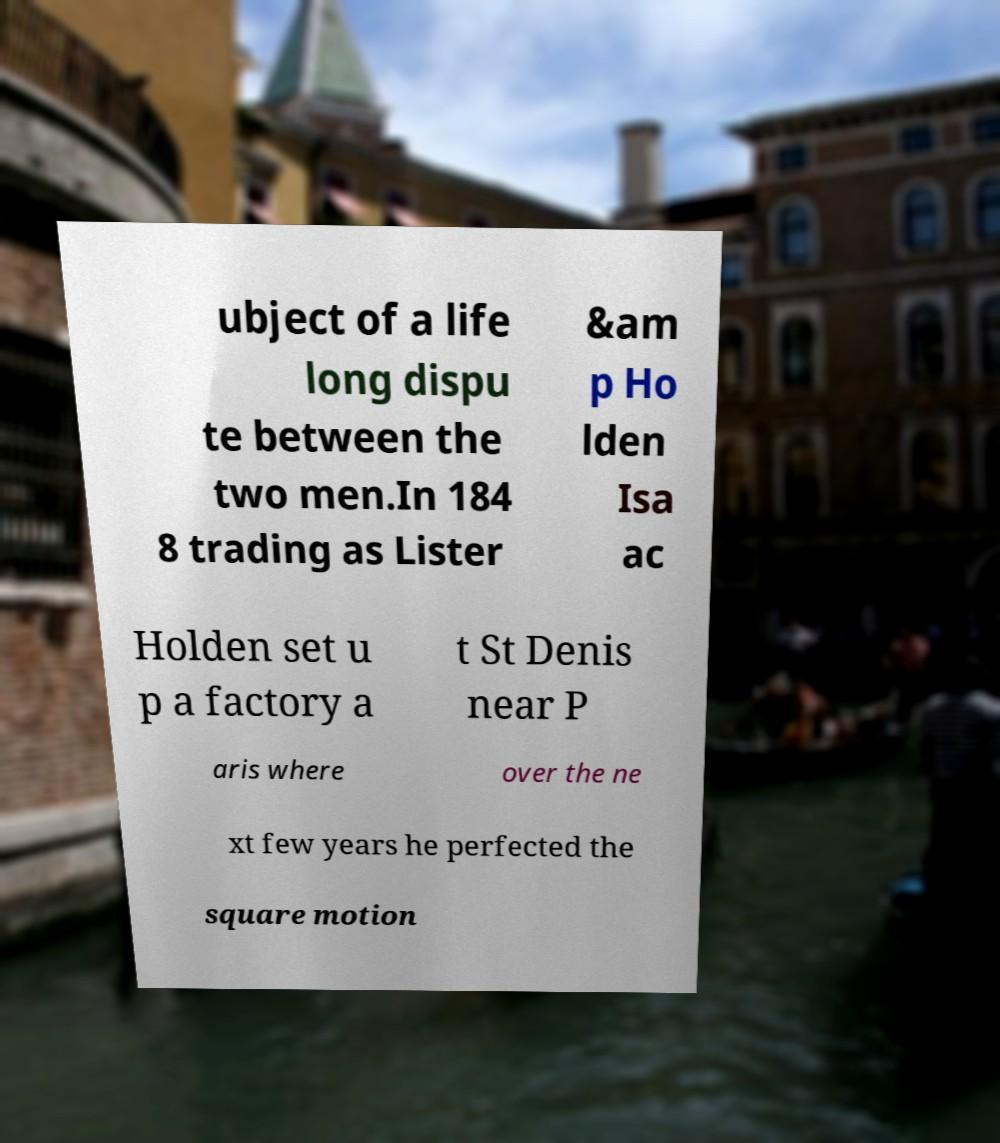Can you read and provide the text displayed in the image?This photo seems to have some interesting text. Can you extract and type it out for me? ubject of a life long dispu te between the two men.In 184 8 trading as Lister &am p Ho lden Isa ac Holden set u p a factory a t St Denis near P aris where over the ne xt few years he perfected the square motion 